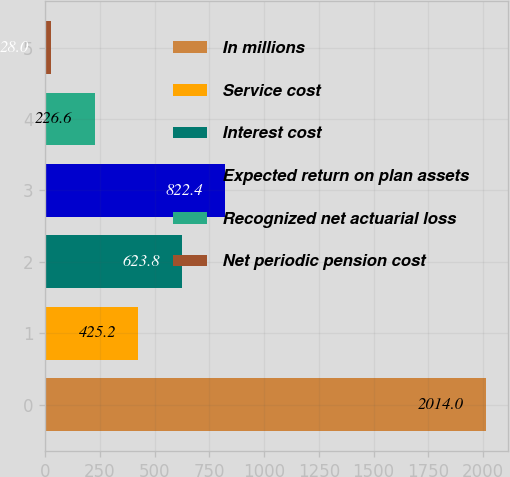Convert chart to OTSL. <chart><loc_0><loc_0><loc_500><loc_500><bar_chart><fcel>In millions<fcel>Service cost<fcel>Interest cost<fcel>Expected return on plan assets<fcel>Recognized net actuarial loss<fcel>Net periodic pension cost<nl><fcel>2014<fcel>425.2<fcel>623.8<fcel>822.4<fcel>226.6<fcel>28<nl></chart> 